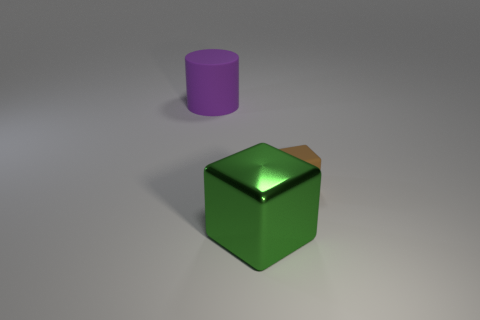What is the purple object made of?
Give a very brief answer. Rubber. Is the material of the large object that is behind the tiny brown block the same as the green cube?
Give a very brief answer. No. What number of matte things are green things or gray objects?
Keep it short and to the point. 0. What is the size of the green shiny cube?
Offer a terse response. Large. Does the brown matte thing have the same size as the cylinder?
Keep it short and to the point. No. What is the cube that is on the left side of the small matte thing made of?
Offer a terse response. Metal. What is the material of the other big thing that is the same shape as the brown matte object?
Your response must be concise. Metal. Is there a cube that is on the right side of the object behind the small rubber cube?
Make the answer very short. Yes. Do the small matte thing and the purple rubber object have the same shape?
Your answer should be compact. No. The brown object that is the same material as the big purple object is what shape?
Provide a short and direct response. Cube. 